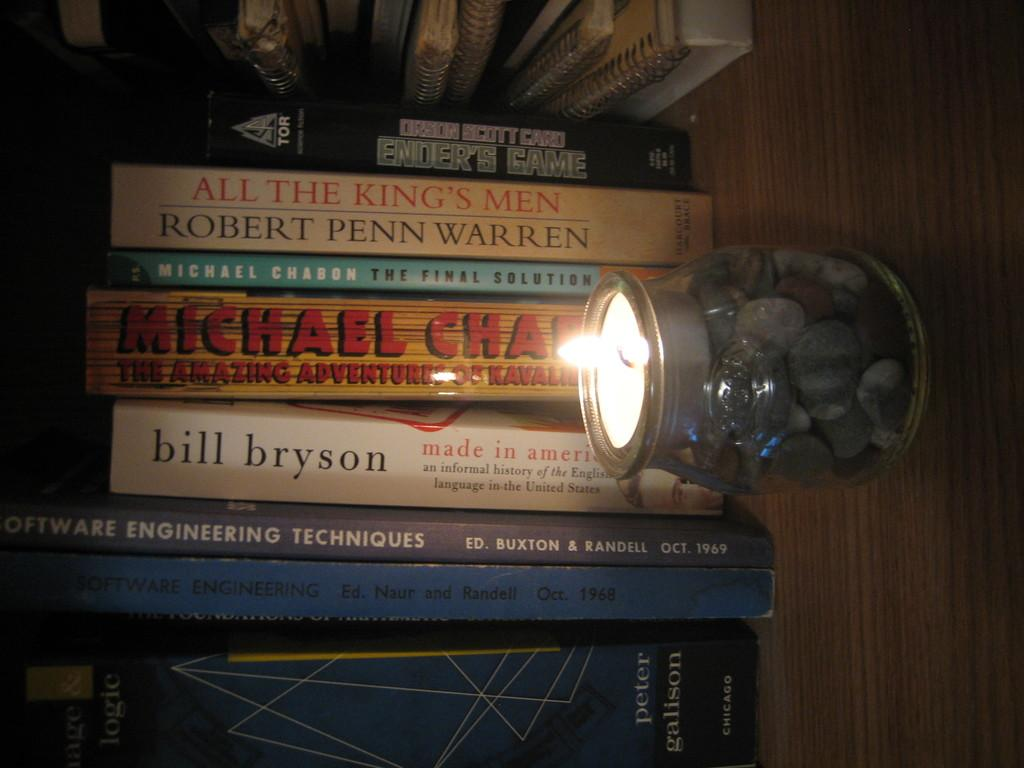<image>
Give a short and clear explanation of the subsequent image. a stack of books that has one of them by 'bill bryson' 